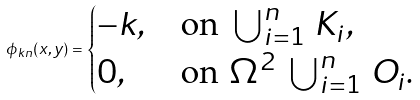Convert formula to latex. <formula><loc_0><loc_0><loc_500><loc_500>\phi _ { k n } ( x , y ) = \begin{cases} - k , & \text {on } \bigcup _ { i = 1 } ^ { n } \, K _ { i } , \\ 0 , & \text {on } \Omega ^ { 2 } \ \bigcup _ { i = 1 } ^ { n } \, O _ { i } . \end{cases}</formula> 